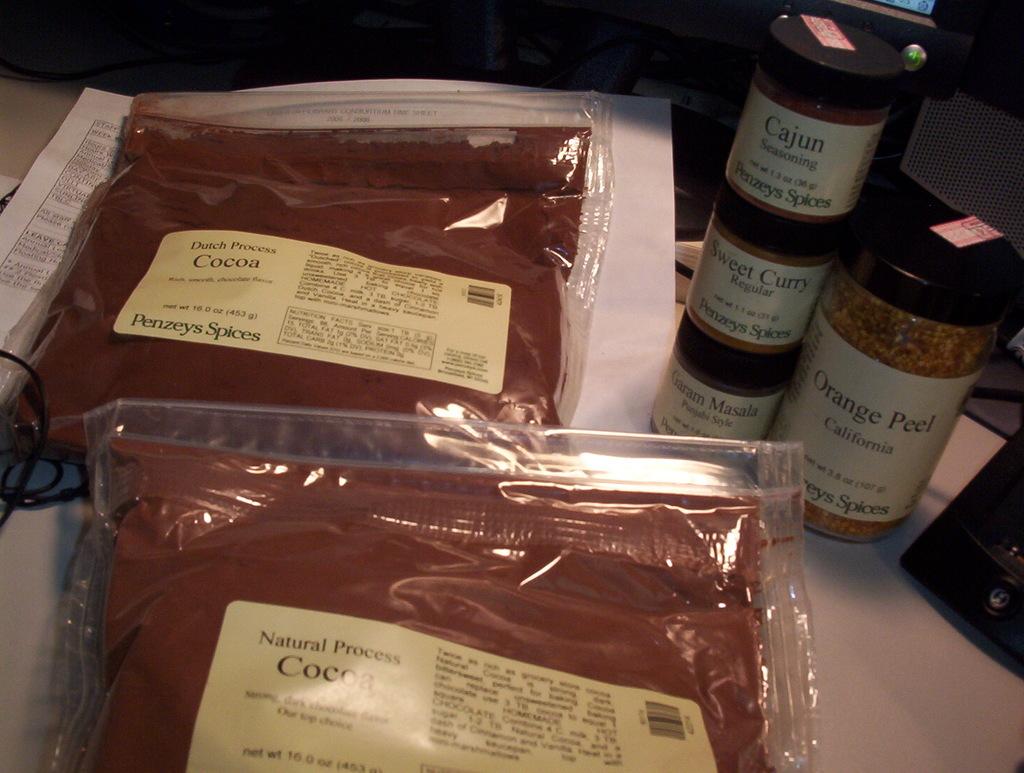Are these natural or synthetic?
Make the answer very short. Natural. 